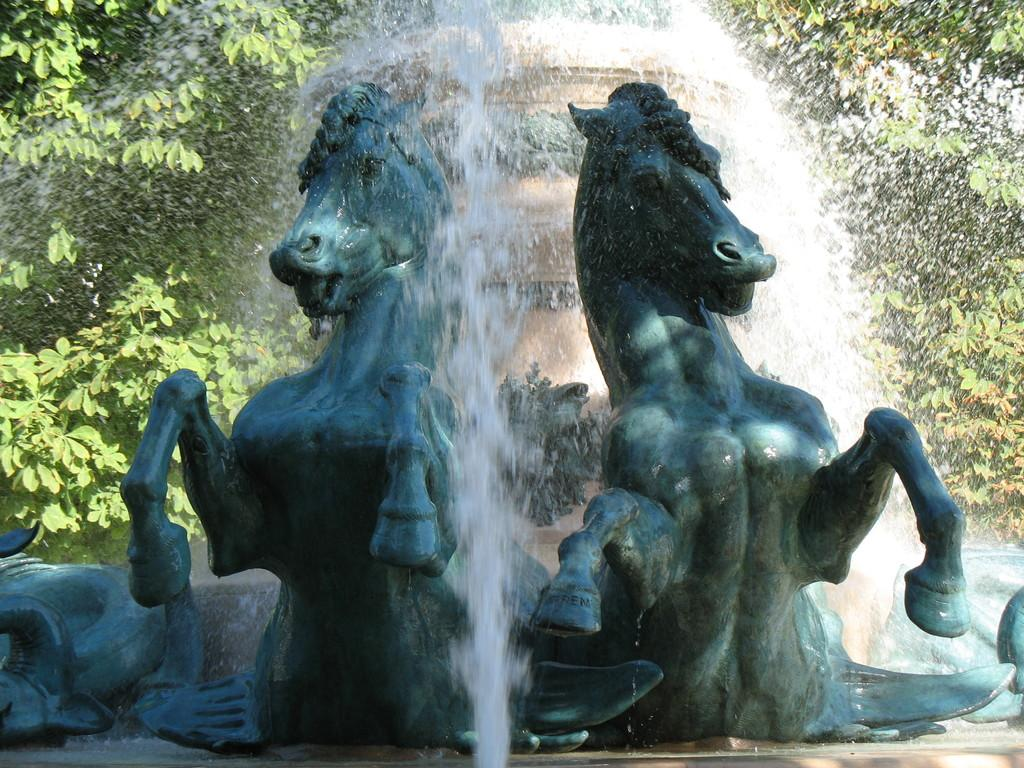What animals are depicted in the image? There is a depiction of horses in the image. What structure can be seen in the image? There is a fountain in the image. What type of natural elements are visible in the background of the image? There are trees in the background of the image. What type of board is being used by the horses in the image? There is no board present in the image; the horses are depicted in a natural setting with a fountain and trees. 